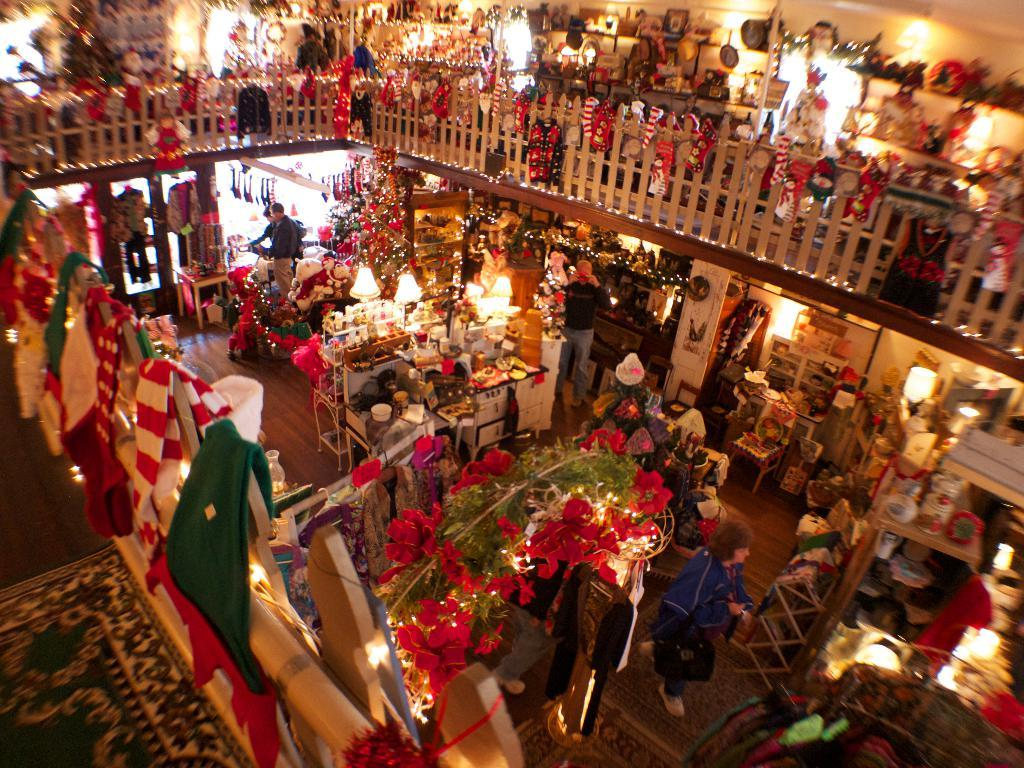What objects are present in the image related to clothing? There are clothes in the image. What type of illumination can be seen in the image? There are lights in the image. What type of natural elements are present in the image? There are flowers in the image. What type of barrier can be seen in the image? There is a fence in the image. What type of structure is visible in the image, and who is inside it? There are people inside a building in the image. Where is the nest located in the image? There is no nest present in the image. What type of fuel is being used by the people inside the building in the image? There is no information about fuel usage in the image. 